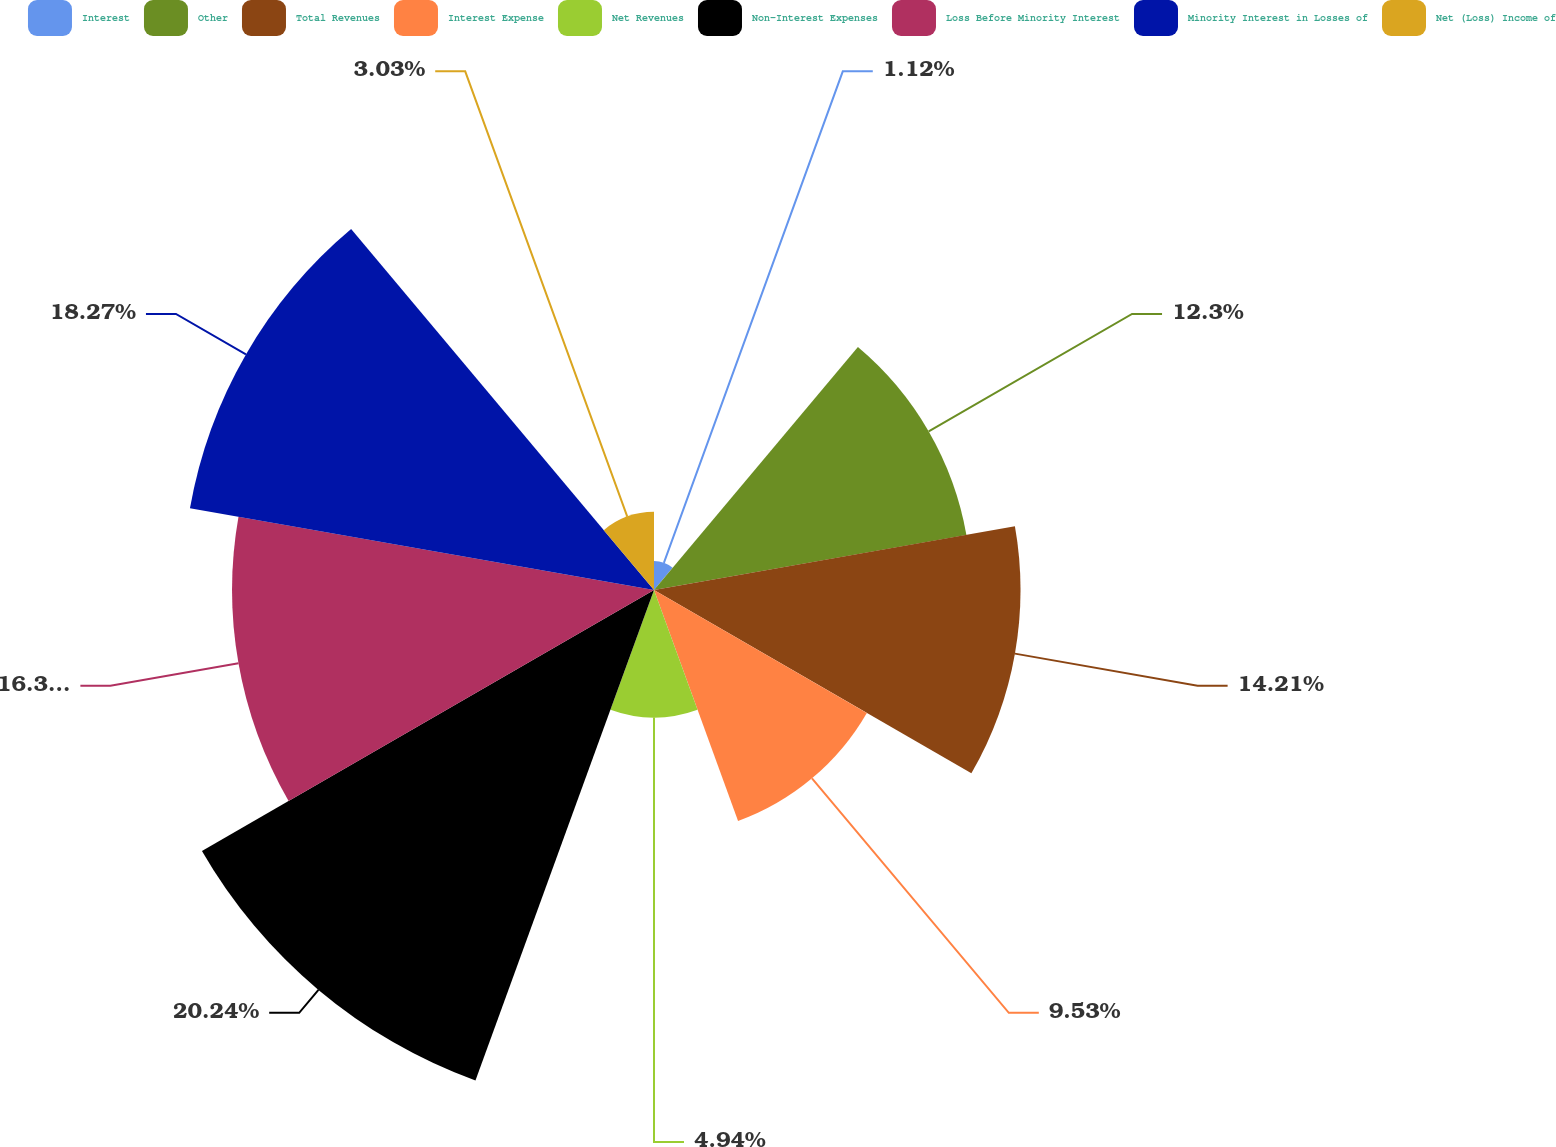<chart> <loc_0><loc_0><loc_500><loc_500><pie_chart><fcel>Interest<fcel>Other<fcel>Total Revenues<fcel>Interest Expense<fcel>Net Revenues<fcel>Non-Interest Expenses<fcel>Loss Before Minority Interest<fcel>Minority Interest in Losses of<fcel>Net (Loss) Income of<nl><fcel>1.12%<fcel>12.3%<fcel>14.21%<fcel>9.53%<fcel>4.94%<fcel>20.24%<fcel>16.36%<fcel>18.27%<fcel>3.03%<nl></chart> 